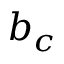<formula> <loc_0><loc_0><loc_500><loc_500>b _ { c }</formula> 